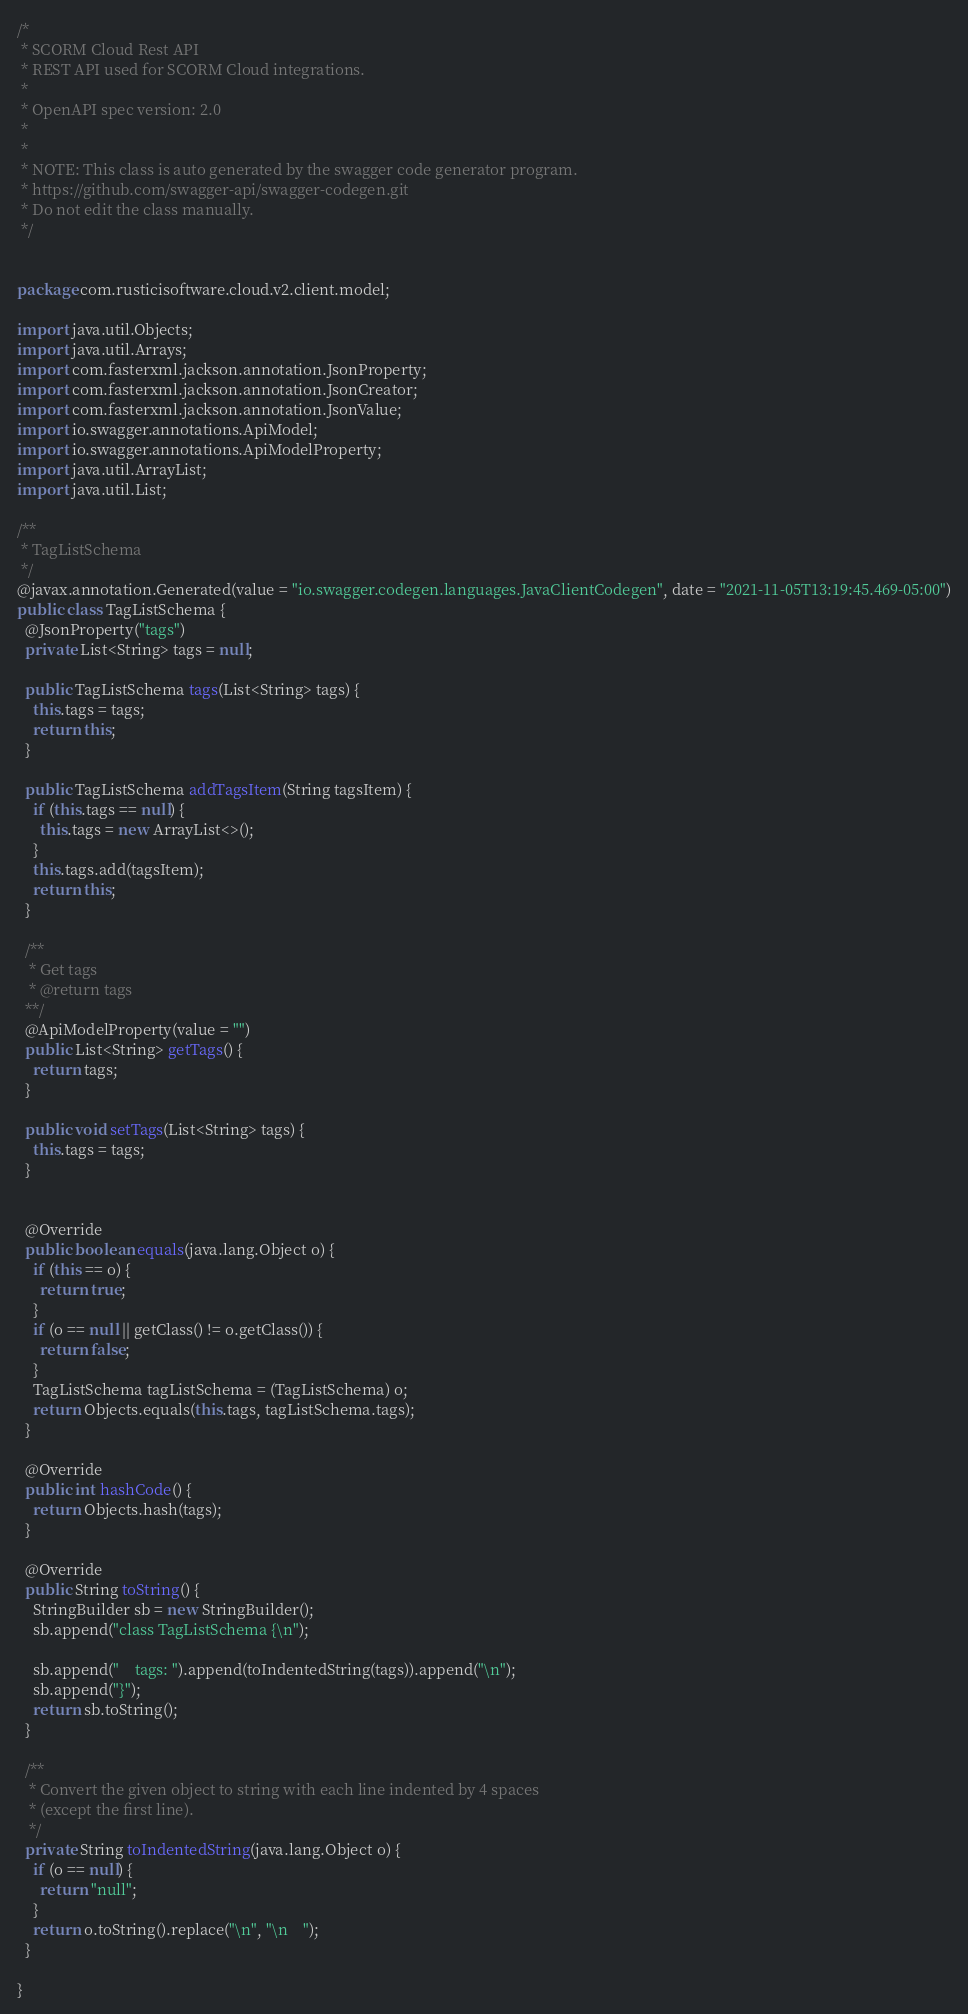<code> <loc_0><loc_0><loc_500><loc_500><_Java_>/*
 * SCORM Cloud Rest API
 * REST API used for SCORM Cloud integrations.
 *
 * OpenAPI spec version: 2.0
 * 
 *
 * NOTE: This class is auto generated by the swagger code generator program.
 * https://github.com/swagger-api/swagger-codegen.git
 * Do not edit the class manually.
 */


package com.rusticisoftware.cloud.v2.client.model;

import java.util.Objects;
import java.util.Arrays;
import com.fasterxml.jackson.annotation.JsonProperty;
import com.fasterxml.jackson.annotation.JsonCreator;
import com.fasterxml.jackson.annotation.JsonValue;
import io.swagger.annotations.ApiModel;
import io.swagger.annotations.ApiModelProperty;
import java.util.ArrayList;
import java.util.List;

/**
 * TagListSchema
 */
@javax.annotation.Generated(value = "io.swagger.codegen.languages.JavaClientCodegen", date = "2021-11-05T13:19:45.469-05:00")
public class TagListSchema {
  @JsonProperty("tags")
  private List<String> tags = null;

  public TagListSchema tags(List<String> tags) {
    this.tags = tags;
    return this;
  }

  public TagListSchema addTagsItem(String tagsItem) {
    if (this.tags == null) {
      this.tags = new ArrayList<>();
    }
    this.tags.add(tagsItem);
    return this;
  }

  /**
   * Get tags
   * @return tags
  **/
  @ApiModelProperty(value = "")
  public List<String> getTags() {
    return tags;
  }

  public void setTags(List<String> tags) {
    this.tags = tags;
  }


  @Override
  public boolean equals(java.lang.Object o) {
    if (this == o) {
      return true;
    }
    if (o == null || getClass() != o.getClass()) {
      return false;
    }
    TagListSchema tagListSchema = (TagListSchema) o;
    return Objects.equals(this.tags, tagListSchema.tags);
  }

  @Override
  public int hashCode() {
    return Objects.hash(tags);
  }

  @Override
  public String toString() {
    StringBuilder sb = new StringBuilder();
    sb.append("class TagListSchema {\n");
    
    sb.append("    tags: ").append(toIndentedString(tags)).append("\n");
    sb.append("}");
    return sb.toString();
  }

  /**
   * Convert the given object to string with each line indented by 4 spaces
   * (except the first line).
   */
  private String toIndentedString(java.lang.Object o) {
    if (o == null) {
      return "null";
    }
    return o.toString().replace("\n", "\n    ");
  }

}

</code> 